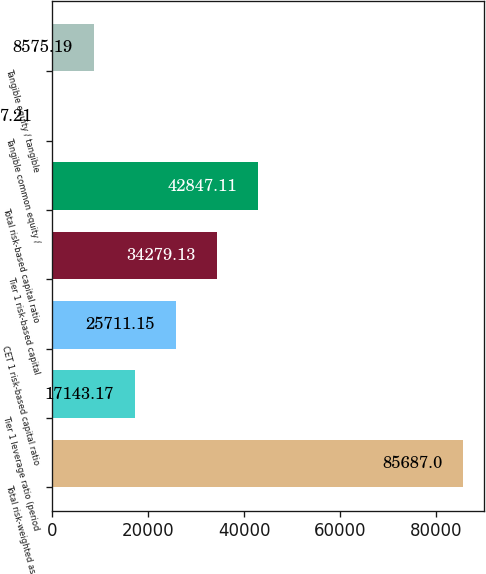<chart> <loc_0><loc_0><loc_500><loc_500><bar_chart><fcel>Total risk-weighted assets<fcel>Tier 1 leverage ratio (period<fcel>CET 1 risk-based capital ratio<fcel>Tier 1 risk-based capital<fcel>Total risk-based capital ratio<fcel>Tangible common equity /<fcel>Tangible equity / tangible<nl><fcel>85687<fcel>17143.2<fcel>25711.2<fcel>34279.1<fcel>42847.1<fcel>7.21<fcel>8575.19<nl></chart> 